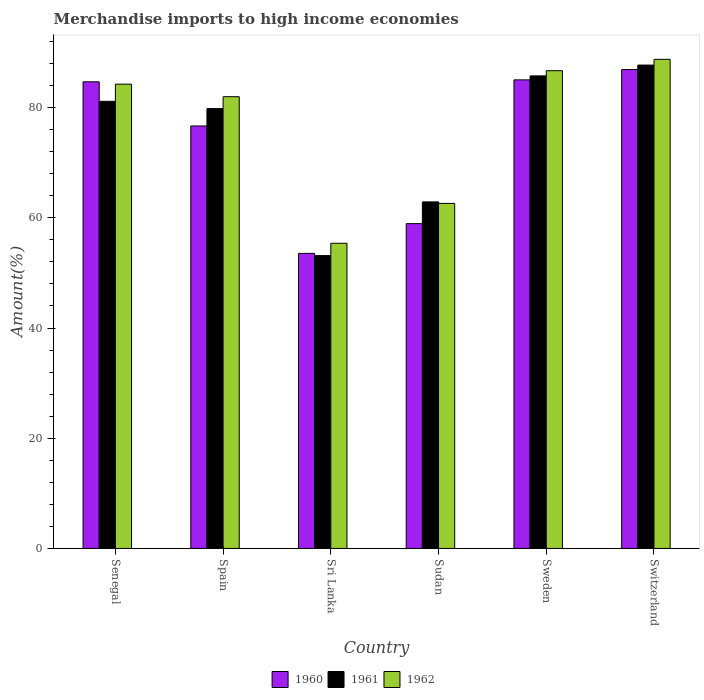How many groups of bars are there?
Offer a very short reply. 6. How many bars are there on the 2nd tick from the left?
Offer a terse response. 3. What is the percentage of amount earned from merchandise imports in 1962 in Spain?
Offer a very short reply. 81.99. Across all countries, what is the maximum percentage of amount earned from merchandise imports in 1962?
Give a very brief answer. 88.77. Across all countries, what is the minimum percentage of amount earned from merchandise imports in 1961?
Your response must be concise. 53.15. In which country was the percentage of amount earned from merchandise imports in 1960 maximum?
Offer a terse response. Switzerland. In which country was the percentage of amount earned from merchandise imports in 1960 minimum?
Provide a succinct answer. Sri Lanka. What is the total percentage of amount earned from merchandise imports in 1960 in the graph?
Your response must be concise. 445.81. What is the difference between the percentage of amount earned from merchandise imports in 1961 in Sri Lanka and that in Sudan?
Give a very brief answer. -9.75. What is the difference between the percentage of amount earned from merchandise imports in 1961 in Spain and the percentage of amount earned from merchandise imports in 1960 in Switzerland?
Provide a short and direct response. -7.09. What is the average percentage of amount earned from merchandise imports in 1960 per country?
Offer a terse response. 74.3. What is the difference between the percentage of amount earned from merchandise imports of/in 1960 and percentage of amount earned from merchandise imports of/in 1961 in Sweden?
Keep it short and to the point. -0.72. What is the ratio of the percentage of amount earned from merchandise imports in 1960 in Senegal to that in Switzerland?
Provide a succinct answer. 0.97. Is the percentage of amount earned from merchandise imports in 1961 in Sweden less than that in Switzerland?
Your answer should be very brief. Yes. What is the difference between the highest and the second highest percentage of amount earned from merchandise imports in 1962?
Your answer should be very brief. 4.51. What is the difference between the highest and the lowest percentage of amount earned from merchandise imports in 1962?
Offer a terse response. 33.38. In how many countries, is the percentage of amount earned from merchandise imports in 1962 greater than the average percentage of amount earned from merchandise imports in 1962 taken over all countries?
Provide a succinct answer. 4. Is the sum of the percentage of amount earned from merchandise imports in 1962 in Sri Lanka and Sudan greater than the maximum percentage of amount earned from merchandise imports in 1960 across all countries?
Your answer should be very brief. Yes. What does the 1st bar from the left in Senegal represents?
Offer a terse response. 1960. What does the 3rd bar from the right in Sri Lanka represents?
Provide a short and direct response. 1960. Are all the bars in the graph horizontal?
Ensure brevity in your answer.  No. Does the graph contain any zero values?
Your response must be concise. No. Where does the legend appear in the graph?
Keep it short and to the point. Bottom center. How many legend labels are there?
Make the answer very short. 3. What is the title of the graph?
Provide a succinct answer. Merchandise imports to high income economies. Does "1978" appear as one of the legend labels in the graph?
Keep it short and to the point. No. What is the label or title of the X-axis?
Ensure brevity in your answer.  Country. What is the label or title of the Y-axis?
Ensure brevity in your answer.  Amount(%). What is the Amount(%) of 1960 in Senegal?
Ensure brevity in your answer.  84.69. What is the Amount(%) in 1961 in Senegal?
Provide a succinct answer. 81.15. What is the Amount(%) of 1962 in Senegal?
Ensure brevity in your answer.  84.26. What is the Amount(%) of 1960 in Spain?
Make the answer very short. 76.67. What is the Amount(%) of 1961 in Spain?
Offer a terse response. 79.83. What is the Amount(%) in 1962 in Spain?
Your answer should be very brief. 81.99. What is the Amount(%) in 1960 in Sri Lanka?
Ensure brevity in your answer.  53.55. What is the Amount(%) in 1961 in Sri Lanka?
Offer a very short reply. 53.15. What is the Amount(%) in 1962 in Sri Lanka?
Offer a terse response. 55.39. What is the Amount(%) of 1960 in Sudan?
Provide a succinct answer. 58.95. What is the Amount(%) of 1961 in Sudan?
Your response must be concise. 62.89. What is the Amount(%) of 1962 in Sudan?
Ensure brevity in your answer.  62.62. What is the Amount(%) in 1960 in Sweden?
Your answer should be compact. 85.04. What is the Amount(%) of 1961 in Sweden?
Your answer should be compact. 85.76. What is the Amount(%) in 1962 in Sweden?
Keep it short and to the point. 86.7. What is the Amount(%) in 1960 in Switzerland?
Your answer should be very brief. 86.92. What is the Amount(%) in 1961 in Switzerland?
Your answer should be compact. 87.73. What is the Amount(%) in 1962 in Switzerland?
Provide a short and direct response. 88.77. Across all countries, what is the maximum Amount(%) in 1960?
Your answer should be very brief. 86.92. Across all countries, what is the maximum Amount(%) in 1961?
Make the answer very short. 87.73. Across all countries, what is the maximum Amount(%) in 1962?
Your answer should be compact. 88.77. Across all countries, what is the minimum Amount(%) of 1960?
Provide a succinct answer. 53.55. Across all countries, what is the minimum Amount(%) in 1961?
Offer a terse response. 53.15. Across all countries, what is the minimum Amount(%) in 1962?
Provide a succinct answer. 55.39. What is the total Amount(%) of 1960 in the graph?
Offer a very short reply. 445.81. What is the total Amount(%) in 1961 in the graph?
Your answer should be very brief. 450.5. What is the total Amount(%) in 1962 in the graph?
Offer a terse response. 459.73. What is the difference between the Amount(%) of 1960 in Senegal and that in Spain?
Keep it short and to the point. 8.01. What is the difference between the Amount(%) in 1961 in Senegal and that in Spain?
Make the answer very short. 1.32. What is the difference between the Amount(%) in 1962 in Senegal and that in Spain?
Give a very brief answer. 2.27. What is the difference between the Amount(%) of 1960 in Senegal and that in Sri Lanka?
Your answer should be very brief. 31.14. What is the difference between the Amount(%) of 1961 in Senegal and that in Sri Lanka?
Offer a very short reply. 28. What is the difference between the Amount(%) of 1962 in Senegal and that in Sri Lanka?
Offer a terse response. 28.88. What is the difference between the Amount(%) of 1960 in Senegal and that in Sudan?
Ensure brevity in your answer.  25.74. What is the difference between the Amount(%) in 1961 in Senegal and that in Sudan?
Your answer should be very brief. 18.25. What is the difference between the Amount(%) of 1962 in Senegal and that in Sudan?
Offer a terse response. 21.64. What is the difference between the Amount(%) in 1960 in Senegal and that in Sweden?
Keep it short and to the point. -0.35. What is the difference between the Amount(%) in 1961 in Senegal and that in Sweden?
Offer a terse response. -4.61. What is the difference between the Amount(%) in 1962 in Senegal and that in Sweden?
Provide a succinct answer. -2.44. What is the difference between the Amount(%) in 1960 in Senegal and that in Switzerland?
Give a very brief answer. -2.23. What is the difference between the Amount(%) of 1961 in Senegal and that in Switzerland?
Offer a very short reply. -6.58. What is the difference between the Amount(%) in 1962 in Senegal and that in Switzerland?
Make the answer very short. -4.51. What is the difference between the Amount(%) of 1960 in Spain and that in Sri Lanka?
Ensure brevity in your answer.  23.12. What is the difference between the Amount(%) in 1961 in Spain and that in Sri Lanka?
Offer a terse response. 26.68. What is the difference between the Amount(%) of 1962 in Spain and that in Sri Lanka?
Your answer should be compact. 26.6. What is the difference between the Amount(%) in 1960 in Spain and that in Sudan?
Keep it short and to the point. 17.72. What is the difference between the Amount(%) of 1961 in Spain and that in Sudan?
Your answer should be very brief. 16.94. What is the difference between the Amount(%) in 1962 in Spain and that in Sudan?
Provide a short and direct response. 19.37. What is the difference between the Amount(%) in 1960 in Spain and that in Sweden?
Offer a terse response. -8.37. What is the difference between the Amount(%) in 1961 in Spain and that in Sweden?
Offer a very short reply. -5.93. What is the difference between the Amount(%) of 1962 in Spain and that in Sweden?
Give a very brief answer. -4.72. What is the difference between the Amount(%) of 1960 in Spain and that in Switzerland?
Offer a terse response. -10.24. What is the difference between the Amount(%) in 1961 in Spain and that in Switzerland?
Offer a very short reply. -7.9. What is the difference between the Amount(%) in 1962 in Spain and that in Switzerland?
Make the answer very short. -6.78. What is the difference between the Amount(%) of 1960 in Sri Lanka and that in Sudan?
Offer a terse response. -5.4. What is the difference between the Amount(%) in 1961 in Sri Lanka and that in Sudan?
Offer a terse response. -9.75. What is the difference between the Amount(%) of 1962 in Sri Lanka and that in Sudan?
Make the answer very short. -7.24. What is the difference between the Amount(%) of 1960 in Sri Lanka and that in Sweden?
Keep it short and to the point. -31.49. What is the difference between the Amount(%) of 1961 in Sri Lanka and that in Sweden?
Make the answer very short. -32.61. What is the difference between the Amount(%) in 1962 in Sri Lanka and that in Sweden?
Keep it short and to the point. -31.32. What is the difference between the Amount(%) of 1960 in Sri Lanka and that in Switzerland?
Your answer should be very brief. -33.37. What is the difference between the Amount(%) of 1961 in Sri Lanka and that in Switzerland?
Ensure brevity in your answer.  -34.58. What is the difference between the Amount(%) of 1962 in Sri Lanka and that in Switzerland?
Provide a short and direct response. -33.38. What is the difference between the Amount(%) in 1960 in Sudan and that in Sweden?
Ensure brevity in your answer.  -26.09. What is the difference between the Amount(%) in 1961 in Sudan and that in Sweden?
Ensure brevity in your answer.  -22.87. What is the difference between the Amount(%) of 1962 in Sudan and that in Sweden?
Give a very brief answer. -24.08. What is the difference between the Amount(%) of 1960 in Sudan and that in Switzerland?
Offer a terse response. -27.97. What is the difference between the Amount(%) in 1961 in Sudan and that in Switzerland?
Provide a short and direct response. -24.83. What is the difference between the Amount(%) of 1962 in Sudan and that in Switzerland?
Ensure brevity in your answer.  -26.15. What is the difference between the Amount(%) in 1960 in Sweden and that in Switzerland?
Your answer should be compact. -1.88. What is the difference between the Amount(%) of 1961 in Sweden and that in Switzerland?
Offer a very short reply. -1.97. What is the difference between the Amount(%) in 1962 in Sweden and that in Switzerland?
Give a very brief answer. -2.06. What is the difference between the Amount(%) of 1960 in Senegal and the Amount(%) of 1961 in Spain?
Make the answer very short. 4.86. What is the difference between the Amount(%) of 1960 in Senegal and the Amount(%) of 1962 in Spain?
Offer a terse response. 2.7. What is the difference between the Amount(%) in 1961 in Senegal and the Amount(%) in 1962 in Spain?
Ensure brevity in your answer.  -0.84. What is the difference between the Amount(%) of 1960 in Senegal and the Amount(%) of 1961 in Sri Lanka?
Offer a terse response. 31.54. What is the difference between the Amount(%) in 1960 in Senegal and the Amount(%) in 1962 in Sri Lanka?
Provide a short and direct response. 29.3. What is the difference between the Amount(%) of 1961 in Senegal and the Amount(%) of 1962 in Sri Lanka?
Ensure brevity in your answer.  25.76. What is the difference between the Amount(%) of 1960 in Senegal and the Amount(%) of 1961 in Sudan?
Offer a terse response. 21.79. What is the difference between the Amount(%) in 1960 in Senegal and the Amount(%) in 1962 in Sudan?
Make the answer very short. 22.06. What is the difference between the Amount(%) in 1961 in Senegal and the Amount(%) in 1962 in Sudan?
Offer a terse response. 18.53. What is the difference between the Amount(%) in 1960 in Senegal and the Amount(%) in 1961 in Sweden?
Your answer should be compact. -1.07. What is the difference between the Amount(%) of 1960 in Senegal and the Amount(%) of 1962 in Sweden?
Your answer should be very brief. -2.02. What is the difference between the Amount(%) of 1961 in Senegal and the Amount(%) of 1962 in Sweden?
Provide a short and direct response. -5.56. What is the difference between the Amount(%) in 1960 in Senegal and the Amount(%) in 1961 in Switzerland?
Make the answer very short. -3.04. What is the difference between the Amount(%) of 1960 in Senegal and the Amount(%) of 1962 in Switzerland?
Your answer should be very brief. -4.08. What is the difference between the Amount(%) in 1961 in Senegal and the Amount(%) in 1962 in Switzerland?
Your response must be concise. -7.62. What is the difference between the Amount(%) in 1960 in Spain and the Amount(%) in 1961 in Sri Lanka?
Offer a terse response. 23.52. What is the difference between the Amount(%) in 1960 in Spain and the Amount(%) in 1962 in Sri Lanka?
Your answer should be very brief. 21.29. What is the difference between the Amount(%) of 1961 in Spain and the Amount(%) of 1962 in Sri Lanka?
Provide a short and direct response. 24.44. What is the difference between the Amount(%) of 1960 in Spain and the Amount(%) of 1961 in Sudan?
Offer a very short reply. 13.78. What is the difference between the Amount(%) in 1960 in Spain and the Amount(%) in 1962 in Sudan?
Provide a short and direct response. 14.05. What is the difference between the Amount(%) of 1961 in Spain and the Amount(%) of 1962 in Sudan?
Keep it short and to the point. 17.21. What is the difference between the Amount(%) in 1960 in Spain and the Amount(%) in 1961 in Sweden?
Offer a terse response. -9.09. What is the difference between the Amount(%) of 1960 in Spain and the Amount(%) of 1962 in Sweden?
Your answer should be compact. -10.03. What is the difference between the Amount(%) in 1961 in Spain and the Amount(%) in 1962 in Sweden?
Ensure brevity in your answer.  -6.88. What is the difference between the Amount(%) in 1960 in Spain and the Amount(%) in 1961 in Switzerland?
Give a very brief answer. -11.05. What is the difference between the Amount(%) in 1960 in Spain and the Amount(%) in 1962 in Switzerland?
Offer a very short reply. -12.1. What is the difference between the Amount(%) in 1961 in Spain and the Amount(%) in 1962 in Switzerland?
Your answer should be compact. -8.94. What is the difference between the Amount(%) in 1960 in Sri Lanka and the Amount(%) in 1961 in Sudan?
Your response must be concise. -9.35. What is the difference between the Amount(%) of 1960 in Sri Lanka and the Amount(%) of 1962 in Sudan?
Keep it short and to the point. -9.07. What is the difference between the Amount(%) of 1961 in Sri Lanka and the Amount(%) of 1962 in Sudan?
Your response must be concise. -9.47. What is the difference between the Amount(%) of 1960 in Sri Lanka and the Amount(%) of 1961 in Sweden?
Ensure brevity in your answer.  -32.21. What is the difference between the Amount(%) of 1960 in Sri Lanka and the Amount(%) of 1962 in Sweden?
Make the answer very short. -33.16. What is the difference between the Amount(%) in 1961 in Sri Lanka and the Amount(%) in 1962 in Sweden?
Offer a very short reply. -33.56. What is the difference between the Amount(%) in 1960 in Sri Lanka and the Amount(%) in 1961 in Switzerland?
Ensure brevity in your answer.  -34.18. What is the difference between the Amount(%) in 1960 in Sri Lanka and the Amount(%) in 1962 in Switzerland?
Keep it short and to the point. -35.22. What is the difference between the Amount(%) in 1961 in Sri Lanka and the Amount(%) in 1962 in Switzerland?
Provide a short and direct response. -35.62. What is the difference between the Amount(%) in 1960 in Sudan and the Amount(%) in 1961 in Sweden?
Provide a short and direct response. -26.81. What is the difference between the Amount(%) in 1960 in Sudan and the Amount(%) in 1962 in Sweden?
Ensure brevity in your answer.  -27.76. What is the difference between the Amount(%) in 1961 in Sudan and the Amount(%) in 1962 in Sweden?
Ensure brevity in your answer.  -23.81. What is the difference between the Amount(%) of 1960 in Sudan and the Amount(%) of 1961 in Switzerland?
Offer a very short reply. -28.78. What is the difference between the Amount(%) in 1960 in Sudan and the Amount(%) in 1962 in Switzerland?
Make the answer very short. -29.82. What is the difference between the Amount(%) of 1961 in Sudan and the Amount(%) of 1962 in Switzerland?
Your answer should be compact. -25.88. What is the difference between the Amount(%) of 1960 in Sweden and the Amount(%) of 1961 in Switzerland?
Make the answer very short. -2.69. What is the difference between the Amount(%) in 1960 in Sweden and the Amount(%) in 1962 in Switzerland?
Offer a very short reply. -3.73. What is the difference between the Amount(%) of 1961 in Sweden and the Amount(%) of 1962 in Switzerland?
Your answer should be very brief. -3.01. What is the average Amount(%) in 1960 per country?
Give a very brief answer. 74.3. What is the average Amount(%) of 1961 per country?
Ensure brevity in your answer.  75.08. What is the average Amount(%) of 1962 per country?
Provide a short and direct response. 76.62. What is the difference between the Amount(%) in 1960 and Amount(%) in 1961 in Senegal?
Keep it short and to the point. 3.54. What is the difference between the Amount(%) in 1960 and Amount(%) in 1962 in Senegal?
Your answer should be very brief. 0.43. What is the difference between the Amount(%) in 1961 and Amount(%) in 1962 in Senegal?
Ensure brevity in your answer.  -3.11. What is the difference between the Amount(%) of 1960 and Amount(%) of 1961 in Spain?
Your answer should be very brief. -3.16. What is the difference between the Amount(%) in 1960 and Amount(%) in 1962 in Spain?
Your answer should be compact. -5.32. What is the difference between the Amount(%) in 1961 and Amount(%) in 1962 in Spain?
Offer a terse response. -2.16. What is the difference between the Amount(%) in 1960 and Amount(%) in 1961 in Sri Lanka?
Your answer should be compact. 0.4. What is the difference between the Amount(%) in 1960 and Amount(%) in 1962 in Sri Lanka?
Your answer should be compact. -1.84. What is the difference between the Amount(%) of 1961 and Amount(%) of 1962 in Sri Lanka?
Give a very brief answer. -2.24. What is the difference between the Amount(%) of 1960 and Amount(%) of 1961 in Sudan?
Your answer should be compact. -3.95. What is the difference between the Amount(%) in 1960 and Amount(%) in 1962 in Sudan?
Your answer should be compact. -3.67. What is the difference between the Amount(%) in 1961 and Amount(%) in 1962 in Sudan?
Your answer should be compact. 0.27. What is the difference between the Amount(%) of 1960 and Amount(%) of 1961 in Sweden?
Your answer should be very brief. -0.72. What is the difference between the Amount(%) of 1960 and Amount(%) of 1962 in Sweden?
Offer a very short reply. -1.66. What is the difference between the Amount(%) of 1961 and Amount(%) of 1962 in Sweden?
Provide a succinct answer. -0.94. What is the difference between the Amount(%) of 1960 and Amount(%) of 1961 in Switzerland?
Your answer should be compact. -0.81. What is the difference between the Amount(%) of 1960 and Amount(%) of 1962 in Switzerland?
Your response must be concise. -1.85. What is the difference between the Amount(%) in 1961 and Amount(%) in 1962 in Switzerland?
Offer a terse response. -1.04. What is the ratio of the Amount(%) of 1960 in Senegal to that in Spain?
Your response must be concise. 1.1. What is the ratio of the Amount(%) of 1961 in Senegal to that in Spain?
Make the answer very short. 1.02. What is the ratio of the Amount(%) of 1962 in Senegal to that in Spain?
Make the answer very short. 1.03. What is the ratio of the Amount(%) in 1960 in Senegal to that in Sri Lanka?
Ensure brevity in your answer.  1.58. What is the ratio of the Amount(%) of 1961 in Senegal to that in Sri Lanka?
Your response must be concise. 1.53. What is the ratio of the Amount(%) in 1962 in Senegal to that in Sri Lanka?
Provide a short and direct response. 1.52. What is the ratio of the Amount(%) in 1960 in Senegal to that in Sudan?
Offer a terse response. 1.44. What is the ratio of the Amount(%) in 1961 in Senegal to that in Sudan?
Your response must be concise. 1.29. What is the ratio of the Amount(%) of 1962 in Senegal to that in Sudan?
Make the answer very short. 1.35. What is the ratio of the Amount(%) in 1961 in Senegal to that in Sweden?
Offer a very short reply. 0.95. What is the ratio of the Amount(%) in 1962 in Senegal to that in Sweden?
Provide a short and direct response. 0.97. What is the ratio of the Amount(%) of 1960 in Senegal to that in Switzerland?
Offer a terse response. 0.97. What is the ratio of the Amount(%) in 1961 in Senegal to that in Switzerland?
Keep it short and to the point. 0.93. What is the ratio of the Amount(%) of 1962 in Senegal to that in Switzerland?
Keep it short and to the point. 0.95. What is the ratio of the Amount(%) in 1960 in Spain to that in Sri Lanka?
Ensure brevity in your answer.  1.43. What is the ratio of the Amount(%) in 1961 in Spain to that in Sri Lanka?
Ensure brevity in your answer.  1.5. What is the ratio of the Amount(%) in 1962 in Spain to that in Sri Lanka?
Keep it short and to the point. 1.48. What is the ratio of the Amount(%) in 1960 in Spain to that in Sudan?
Offer a very short reply. 1.3. What is the ratio of the Amount(%) in 1961 in Spain to that in Sudan?
Ensure brevity in your answer.  1.27. What is the ratio of the Amount(%) of 1962 in Spain to that in Sudan?
Offer a very short reply. 1.31. What is the ratio of the Amount(%) of 1960 in Spain to that in Sweden?
Your response must be concise. 0.9. What is the ratio of the Amount(%) of 1961 in Spain to that in Sweden?
Provide a succinct answer. 0.93. What is the ratio of the Amount(%) of 1962 in Spain to that in Sweden?
Keep it short and to the point. 0.95. What is the ratio of the Amount(%) of 1960 in Spain to that in Switzerland?
Offer a very short reply. 0.88. What is the ratio of the Amount(%) in 1961 in Spain to that in Switzerland?
Your answer should be compact. 0.91. What is the ratio of the Amount(%) in 1962 in Spain to that in Switzerland?
Make the answer very short. 0.92. What is the ratio of the Amount(%) in 1960 in Sri Lanka to that in Sudan?
Make the answer very short. 0.91. What is the ratio of the Amount(%) of 1961 in Sri Lanka to that in Sudan?
Offer a terse response. 0.84. What is the ratio of the Amount(%) of 1962 in Sri Lanka to that in Sudan?
Your response must be concise. 0.88. What is the ratio of the Amount(%) of 1960 in Sri Lanka to that in Sweden?
Your answer should be very brief. 0.63. What is the ratio of the Amount(%) in 1961 in Sri Lanka to that in Sweden?
Provide a succinct answer. 0.62. What is the ratio of the Amount(%) in 1962 in Sri Lanka to that in Sweden?
Provide a short and direct response. 0.64. What is the ratio of the Amount(%) of 1960 in Sri Lanka to that in Switzerland?
Make the answer very short. 0.62. What is the ratio of the Amount(%) in 1961 in Sri Lanka to that in Switzerland?
Your response must be concise. 0.61. What is the ratio of the Amount(%) in 1962 in Sri Lanka to that in Switzerland?
Keep it short and to the point. 0.62. What is the ratio of the Amount(%) of 1960 in Sudan to that in Sweden?
Keep it short and to the point. 0.69. What is the ratio of the Amount(%) in 1961 in Sudan to that in Sweden?
Provide a short and direct response. 0.73. What is the ratio of the Amount(%) of 1962 in Sudan to that in Sweden?
Offer a very short reply. 0.72. What is the ratio of the Amount(%) in 1960 in Sudan to that in Switzerland?
Your response must be concise. 0.68. What is the ratio of the Amount(%) in 1961 in Sudan to that in Switzerland?
Your answer should be compact. 0.72. What is the ratio of the Amount(%) of 1962 in Sudan to that in Switzerland?
Make the answer very short. 0.71. What is the ratio of the Amount(%) of 1960 in Sweden to that in Switzerland?
Make the answer very short. 0.98. What is the ratio of the Amount(%) in 1961 in Sweden to that in Switzerland?
Your answer should be compact. 0.98. What is the ratio of the Amount(%) in 1962 in Sweden to that in Switzerland?
Your answer should be compact. 0.98. What is the difference between the highest and the second highest Amount(%) in 1960?
Make the answer very short. 1.88. What is the difference between the highest and the second highest Amount(%) in 1961?
Ensure brevity in your answer.  1.97. What is the difference between the highest and the second highest Amount(%) in 1962?
Ensure brevity in your answer.  2.06. What is the difference between the highest and the lowest Amount(%) of 1960?
Your answer should be very brief. 33.37. What is the difference between the highest and the lowest Amount(%) of 1961?
Your answer should be compact. 34.58. What is the difference between the highest and the lowest Amount(%) of 1962?
Provide a succinct answer. 33.38. 